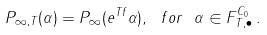Convert formula to latex. <formula><loc_0><loc_0><loc_500><loc_500>P _ { \infty , T } ( \alpha ) = P _ { \infty } ( e ^ { T f } \alpha ) , \ f o r \ \alpha \in F ^ { C _ { 0 } } _ { T , \bullet } \, .</formula> 